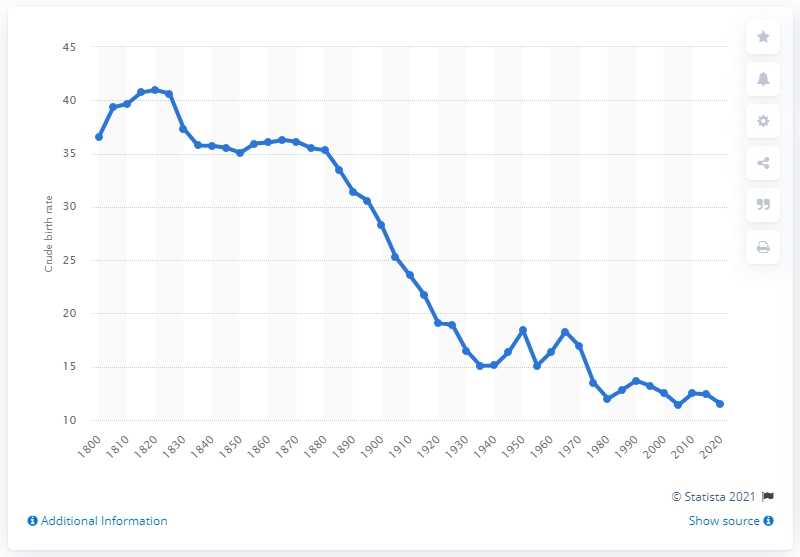Point out several critical features in this image. The crude birth rate is expected to be 11.5 in 2020. 